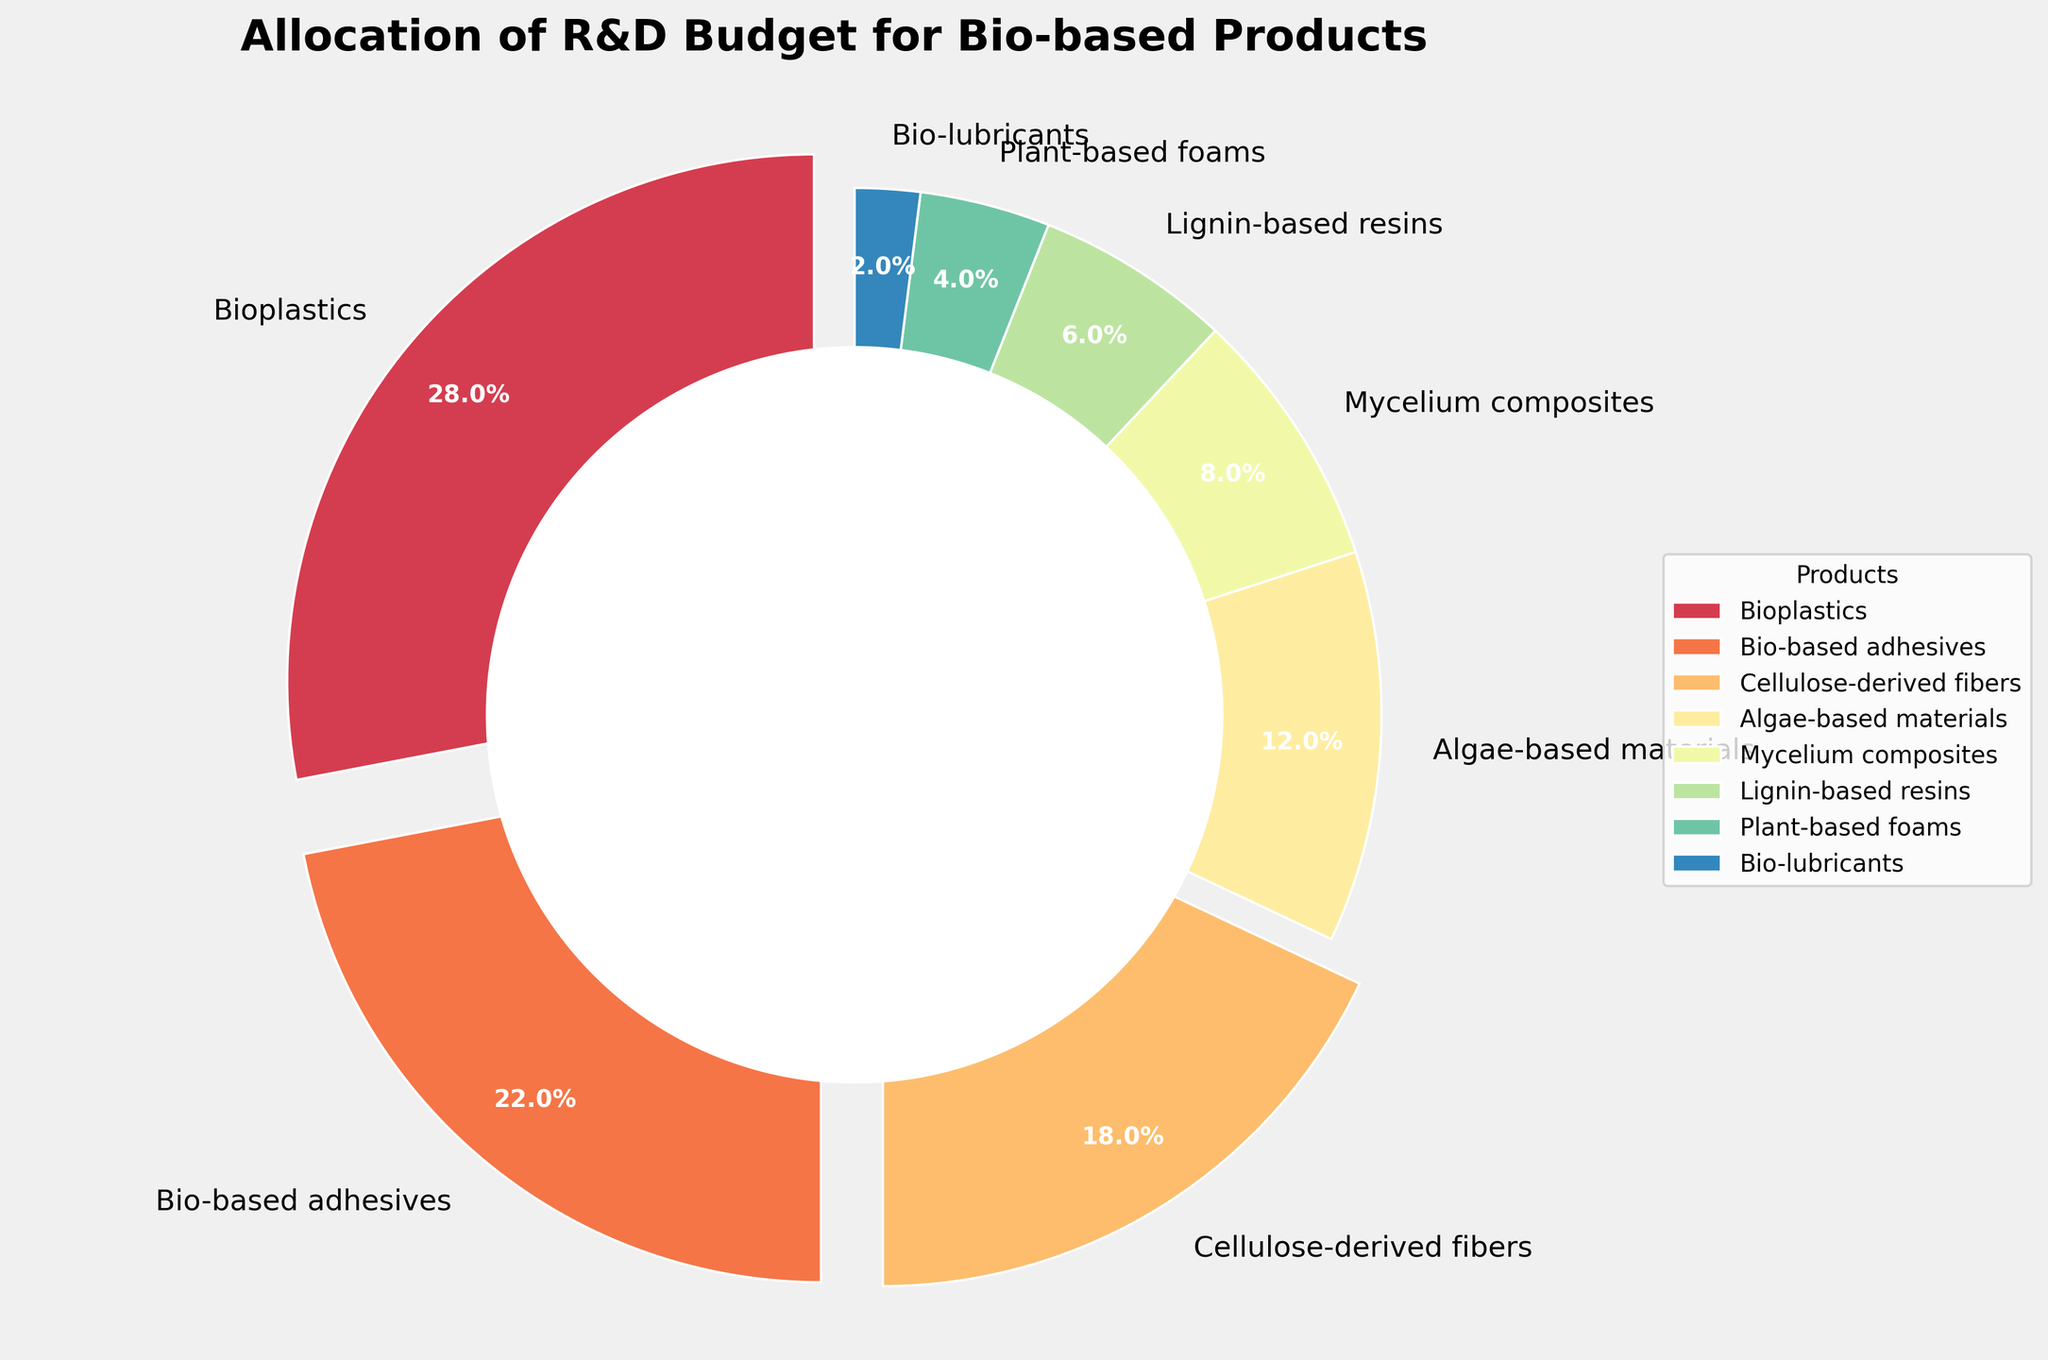Which bio-based product receives the highest percentage of the R&D budget? The "Bioplastics" segment has the highest percentage indicated by the largest section of the pie chart.
Answer: Bioplastics What is the combined budget percentage for Bio-based adhesives and Cellulose-derived fibers? The percentage for Bio-based adhesives is 22%, and for Cellulose-derived fibers is 18%. Adding them gives 22% + 18% = 40%.
Answer: 40% Which product gets double the budget percentage of Algae-based materials? Algae-based materials have 12%, and double of 12% is 24%. None of the products have exactly 24%, but Bioplastics (28%) is closest and higher.
Answer: None (closest: Bioplastics) What is the difference between the budget percentages of Bioplastics and Plant-based foams? Bioplastics have 28%, and Plant-based foams have 4%. The difference is 28% - 4% = 24%.
Answer: 24% Do Mycelium composites receive more budget than Lignin-based resins? Mycelium composites have 8%, and Lignin-based resins have 6%. Since 8% is greater than 6%, Mycelium composites receive more.
Answer: Yes Which color represents Bio-lubricants in the pie chart? Bio-lubricants, indicated by the smallest section in the pie chart, are represented by the corresponding visual cues.
Answer: Typically a lighter/dimmer color depending on the palette (specific color identification needed from the visual) How many products receive the budget percentage below 10%? Products with less than 10% are Mycelium composites (8%), Lignin-based resins (6%), Plant-based foams (4%), and Bio-lubricants (2%): a total of 4 products.
Answer: 4 What is the average budget percentage allocation for all products? Sum all percentages: 28 + 22 + 18 + 12 + 8 + 6 + 4 + 2 = 100. There are 8 products, so 100 / 8 = 12.5%.
Answer: 12.5% Which bio-based product has its percentage represented with an exploded slice in the pie chart? The exploded slices are those with a budget percentage higher than 15%, that is, Bioplastics (28%), Bio-based adhesives (22%), and Cellulose-derived fibers (18%).
Answer: Bioplastics, Bio-based adhesives, Cellulose-derived fibers What is the total budget percentage for products receiving less than 10% each? Add percentages for Mycelium composites (8%), Lignin-based resins (6%), Plant-based foams (4%), and Bio-lubricants (2%): 8% + 6% + 4% + 2% = 20%.
Answer: 20% 